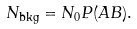<formula> <loc_0><loc_0><loc_500><loc_500>N _ { \text {bkg} } = N _ { 0 } P ( A B ) .</formula> 